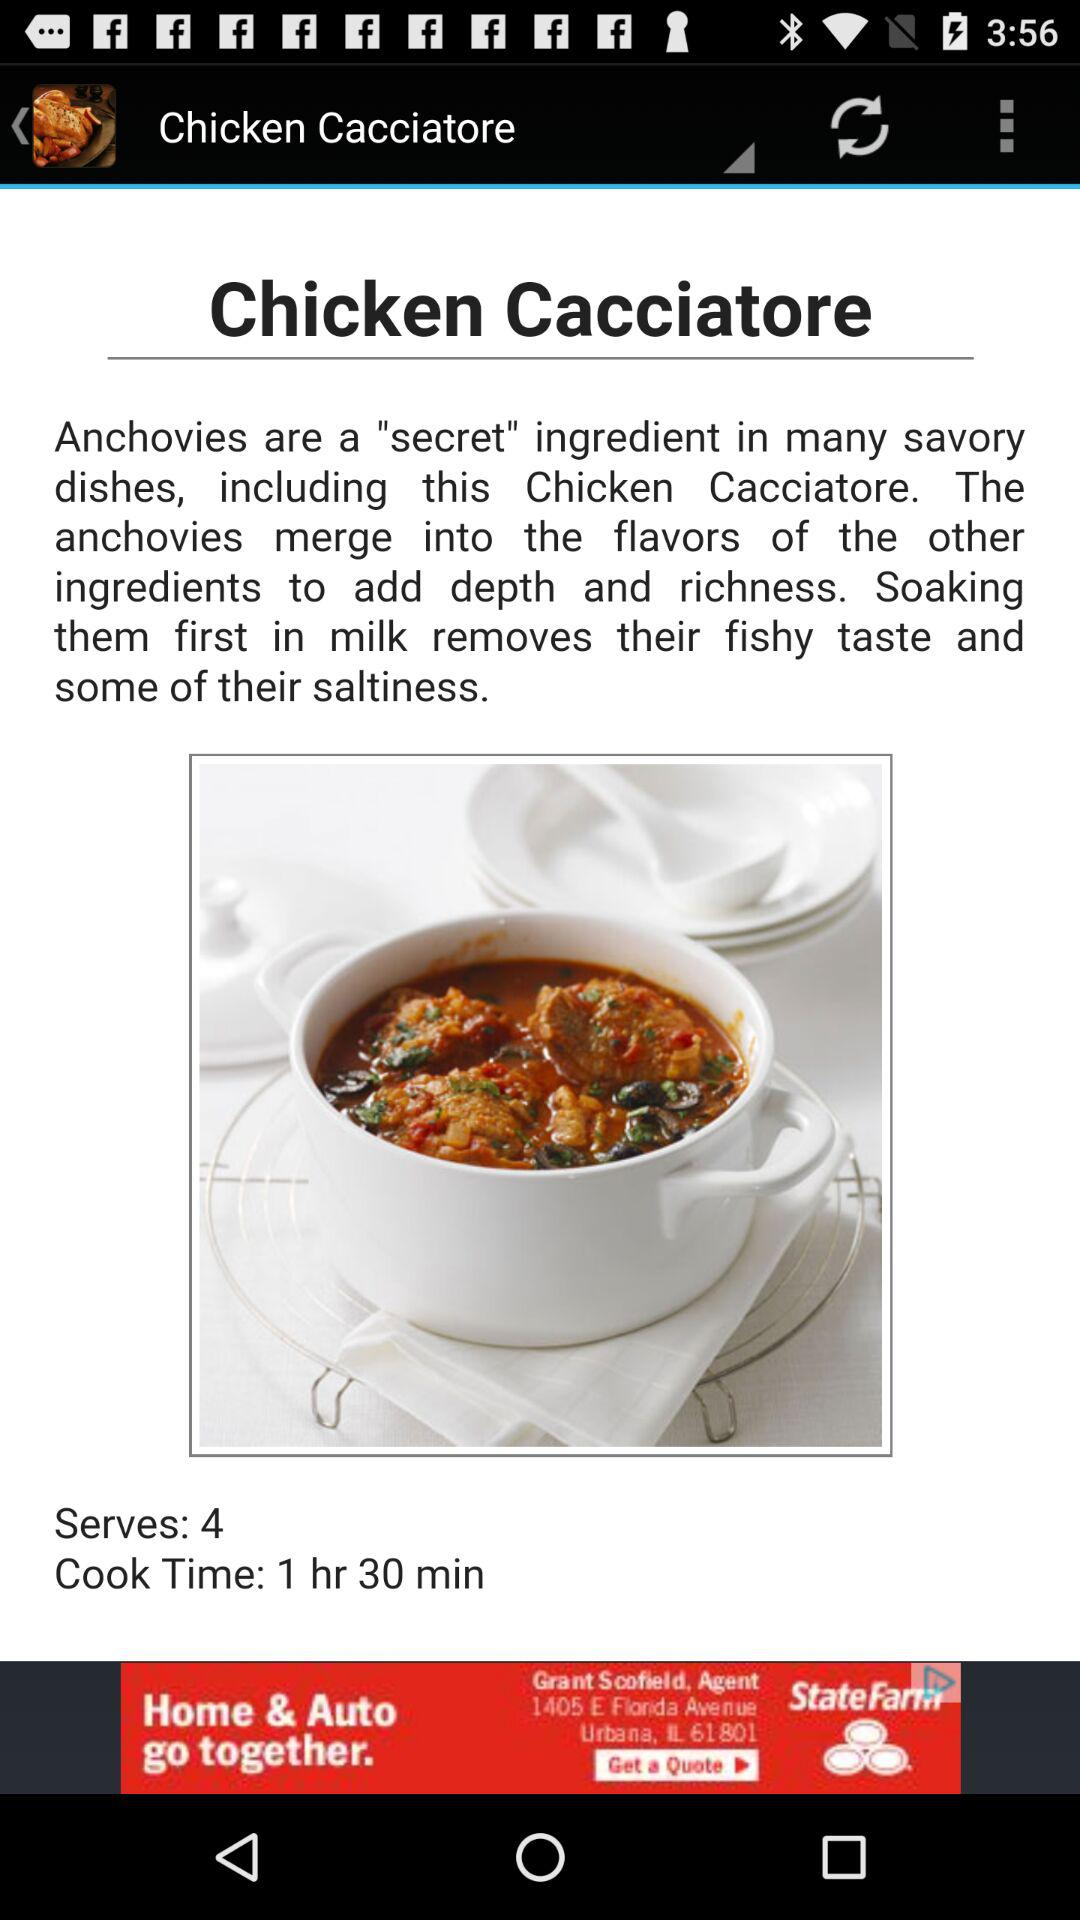What's the total cooking time? The total cooking time is 1 hour 30 minutes. 